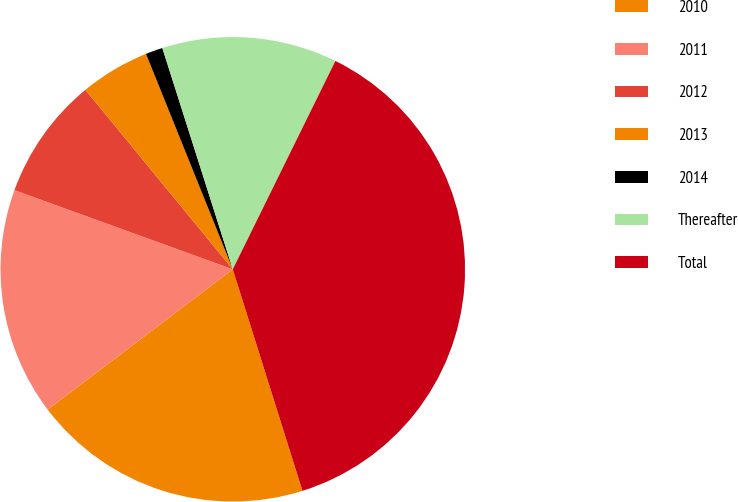Convert chart to OTSL. <chart><loc_0><loc_0><loc_500><loc_500><pie_chart><fcel>2010<fcel>2011<fcel>2012<fcel>2013<fcel>2014<fcel>Thereafter<fcel>Total<nl><fcel>19.53%<fcel>15.86%<fcel>8.52%<fcel>4.85%<fcel>1.19%<fcel>12.19%<fcel>37.87%<nl></chart> 